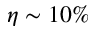<formula> <loc_0><loc_0><loc_500><loc_500>\eta \sim 1 0 \%</formula> 